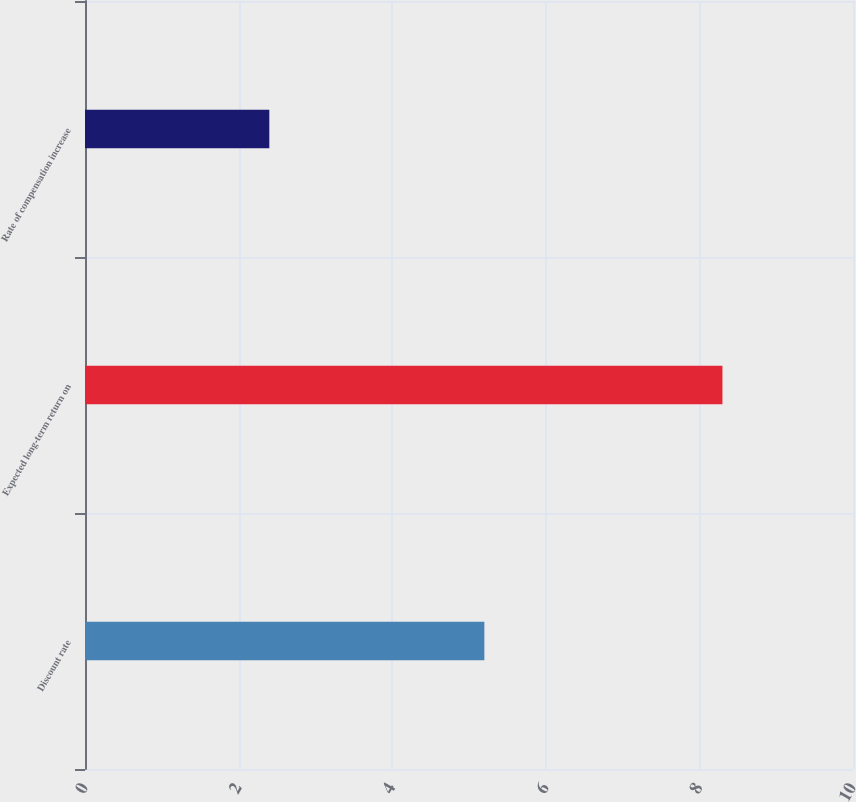Convert chart to OTSL. <chart><loc_0><loc_0><loc_500><loc_500><bar_chart><fcel>Discount rate<fcel>Expected long-term return on<fcel>Rate of compensation increase<nl><fcel>5.2<fcel>8.3<fcel>2.4<nl></chart> 